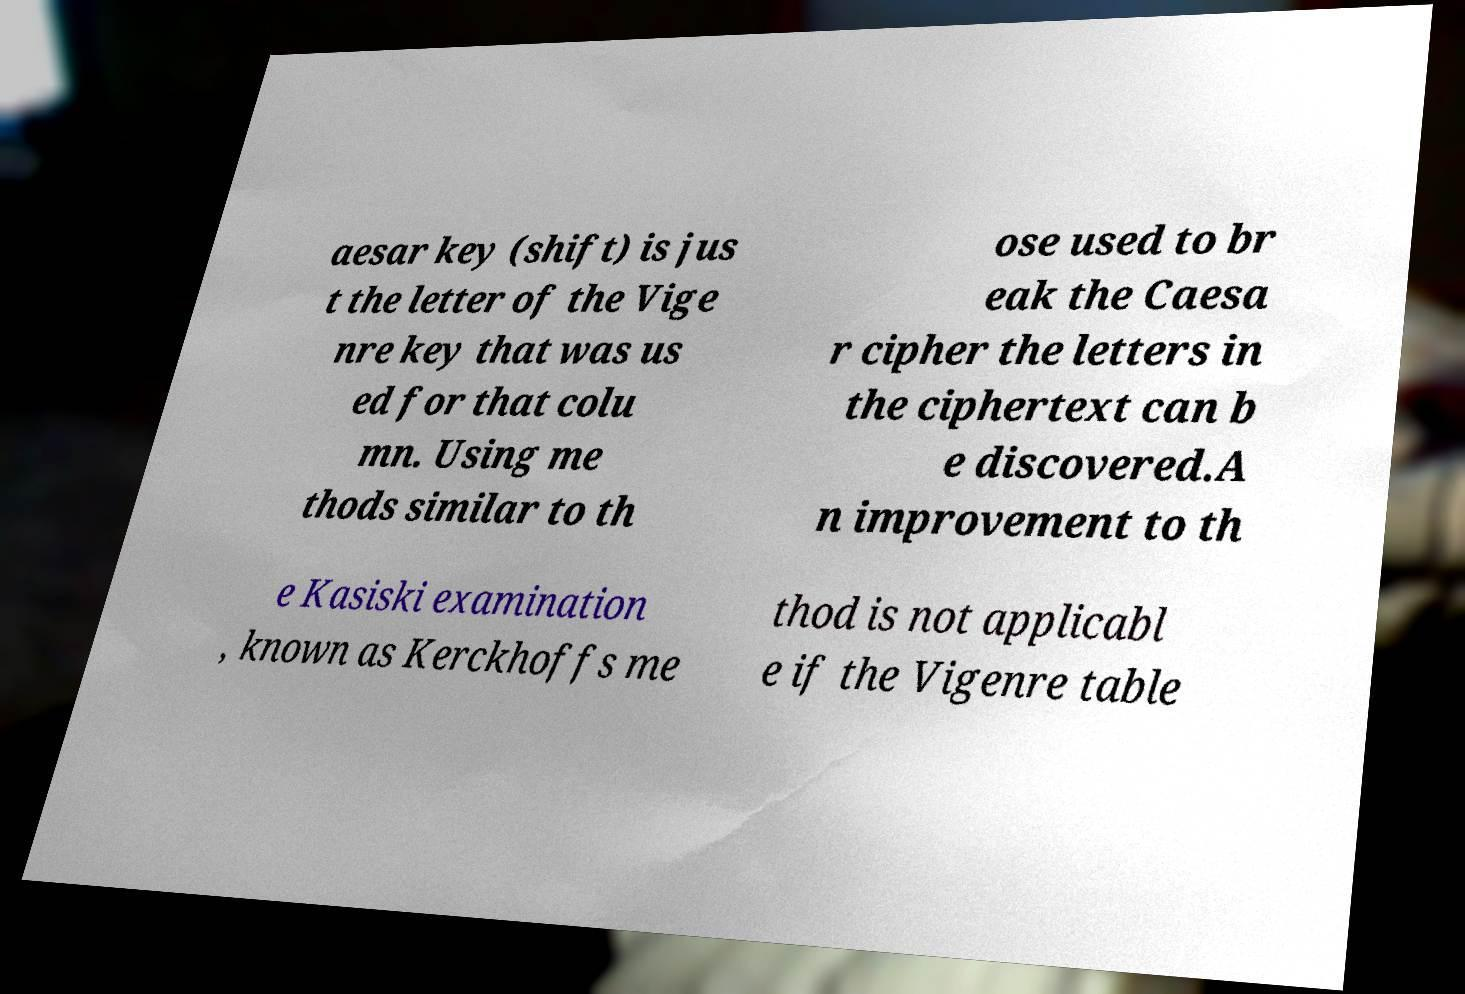Can you accurately transcribe the text from the provided image for me? aesar key (shift) is jus t the letter of the Vige nre key that was us ed for that colu mn. Using me thods similar to th ose used to br eak the Caesa r cipher the letters in the ciphertext can b e discovered.A n improvement to th e Kasiski examination , known as Kerckhoffs me thod is not applicabl e if the Vigenre table 